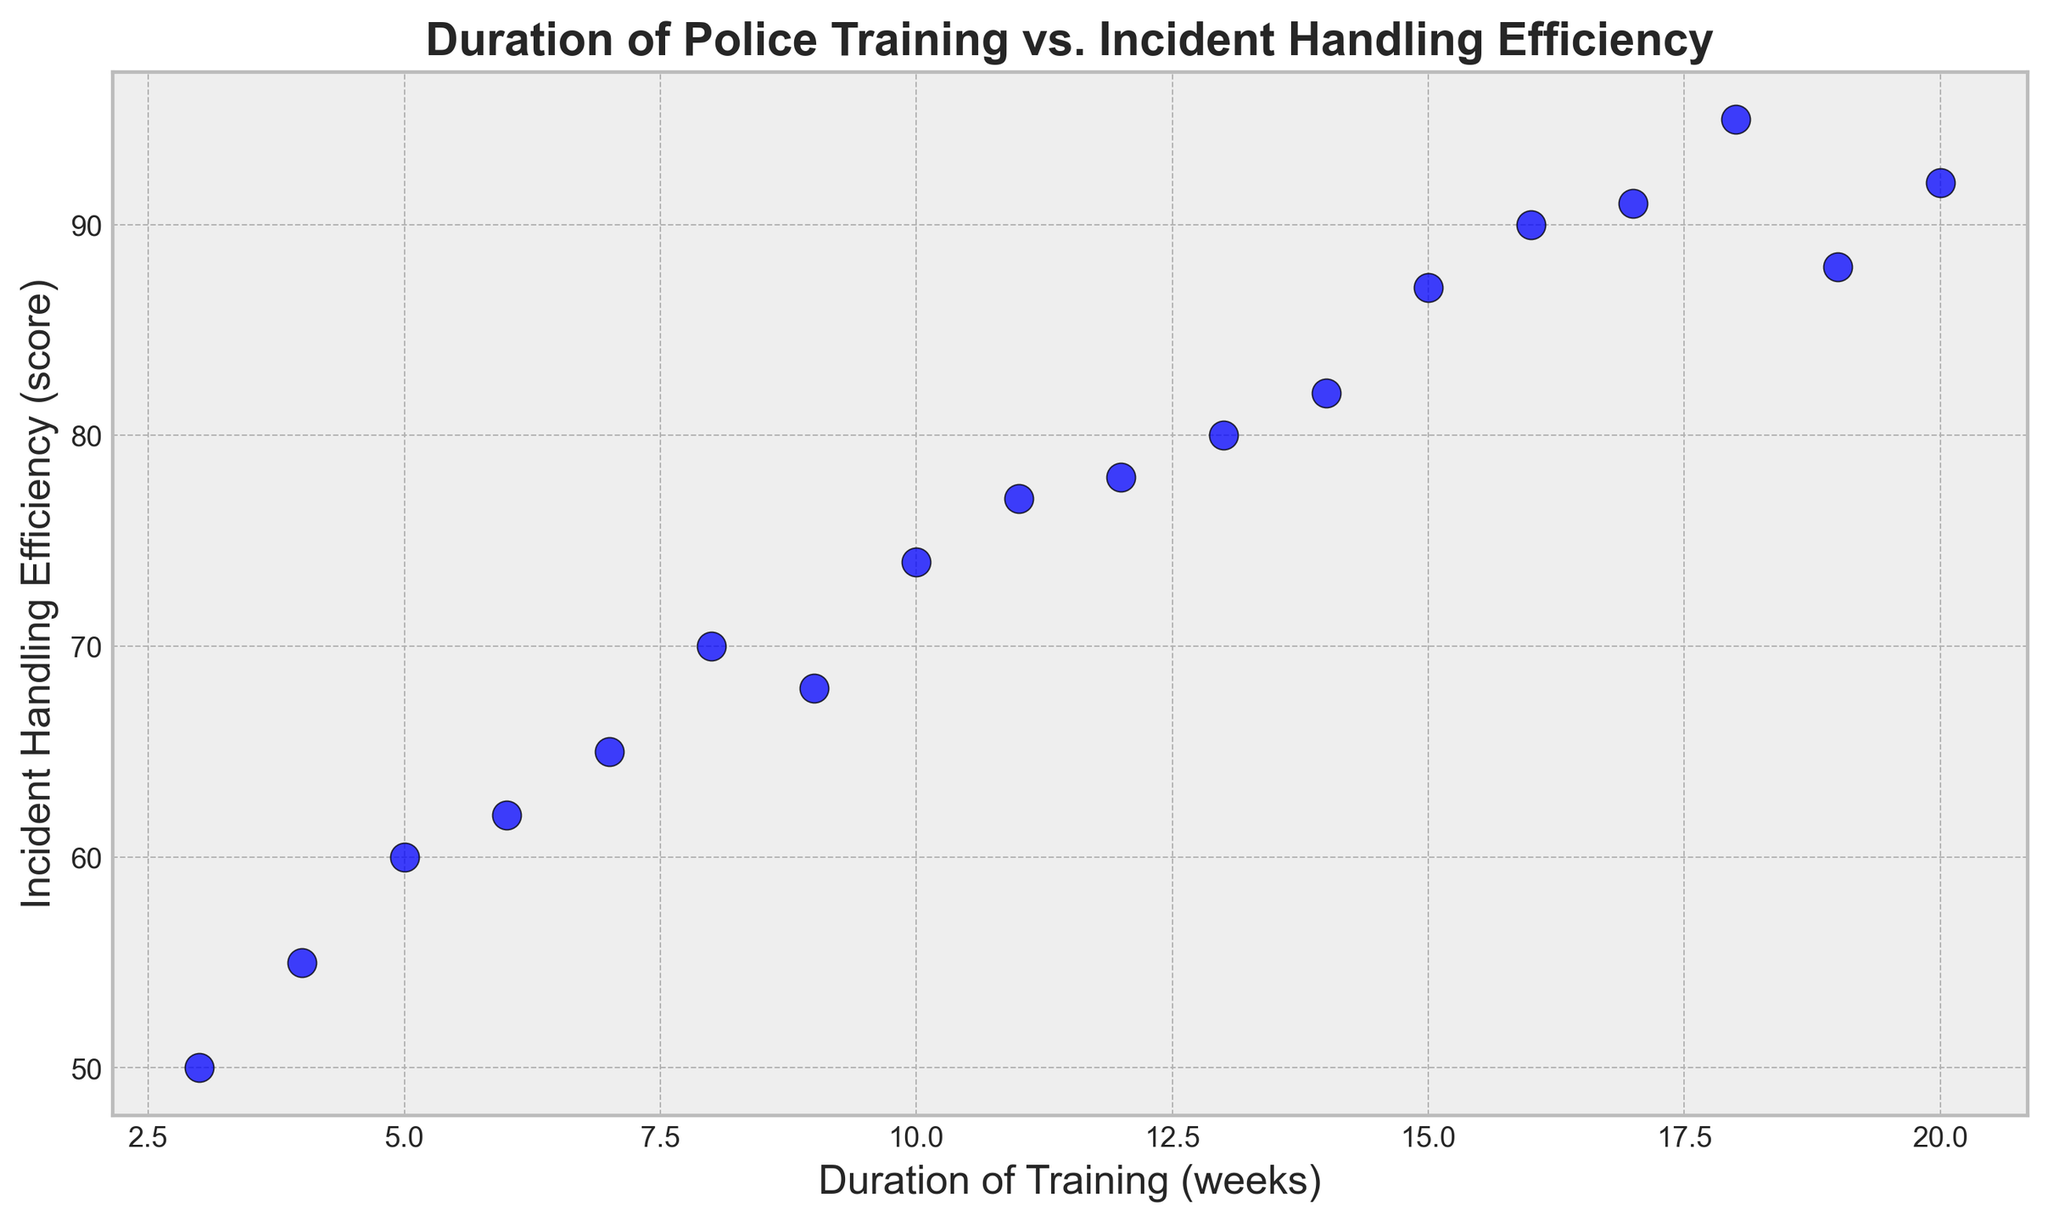What's the approximate highest Incident Handling Efficiency score? The highest point on the scatter plot on the Incident Handling Efficiency axis is at 95. This indicates that the maximum efficiency score is 95.
Answer: 95 What is the shortest Duration of Training observed in the plot? The scatter plot shows the shortest duration of training on the x-axis, which is 3 weeks.
Answer: 3 weeks How does the Incident Handling Efficiency for an officer with 20 weeks of training compare to one with 3 weeks of training? An officer with 20 weeks of training has an efficiency score of 92, while an officer with 3 weeks of training scores 50, indicating that the officer with longer training has significantly higher efficiency.
Answer: 92 vs 50 Is there a generally observable trend between the Duration of Training and Incident Handling Efficiency? Observing the scatter plot, it seems that as the duration of training increases, the incident handling efficiency also tends to increase. The points generally rise as one moves to the right.
Answer: Positive correlation What is the average Incident Handling Efficiency for officers with exactly 15 and 16 weeks of training? The plot shows the efficiencies for 15 and 16 weeks of training as 87 and 90, respectively. The average is calculated as (87 + 90) / 2 = 88.5.
Answer: 88.5 Which duration of training achieved a score of exactly 70 in Incident Handling Efficiency? On the scatter plot, there is a point corresponding to 70 in efficiency which is located at 8 weeks of training.
Answer: 8 weeks How much higher is the highest efficiency score compared to the lowest efficiency score? The highest efficiency score is 95, and the lowest is 50. Subtracting the lowest from the highest gives 95 - 50 = 45.
Answer: 45 What is the most frequent range of training duration based on the scatter plot? The scatter plot shows most points concentrated between 10 and 16 weeks on the x-axis.
Answer: 10-16 weeks Is there a point for which the Incident Handling Efficiency score is below 60? If so, for what duration of training? Yes, there is a point with an efficiency score below 60 (specifically 55), which corresponds to 4 weeks of training.
Answer: 4 weeks Do any of the points lie directly on the average efficiency line if plotted? If we consider the average efficiency of all visible points, none appear to lie directly on an average line. The calculation of the exact average isn't shown, but visual observation confirms this assumption.
Answer: No 